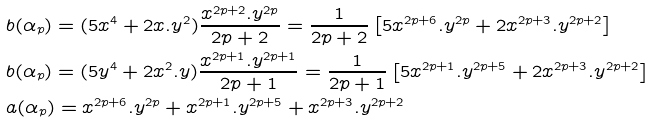Convert formula to latex. <formula><loc_0><loc_0><loc_500><loc_500>& b ( \alpha _ { p } ) = ( 5 x ^ { 4 } + 2 x . y ^ { 2 } ) \frac { x ^ { 2 p + 2 } . y ^ { 2 p } } { 2 p + 2 } = \frac { 1 } { 2 p + 2 } \left [ 5 x ^ { 2 p + 6 } . y ^ { 2 p } + 2 x ^ { 2 p + 3 } . y ^ { 2 p + 2 } \right ] \\ & b ( \alpha _ { p } ) = ( 5 y ^ { 4 } + 2 x ^ { 2 } . y ) \frac { x ^ { 2 p + 1 } . y ^ { 2 p + 1 } } { 2 p + 1 } = \frac { 1 } { 2 p + 1 } \left [ 5 x ^ { 2 p + 1 } . y ^ { 2 p + 5 } + 2 x ^ { 2 p + 3 } . y ^ { 2 p + 2 } \right ] \\ & a ( \alpha _ { p } ) = x ^ { 2 p + 6 } . y ^ { 2 p } + x ^ { 2 p + 1 } . y ^ { 2 p + 5 } + x ^ { 2 p + 3 } . y ^ { 2 p + 2 }</formula> 